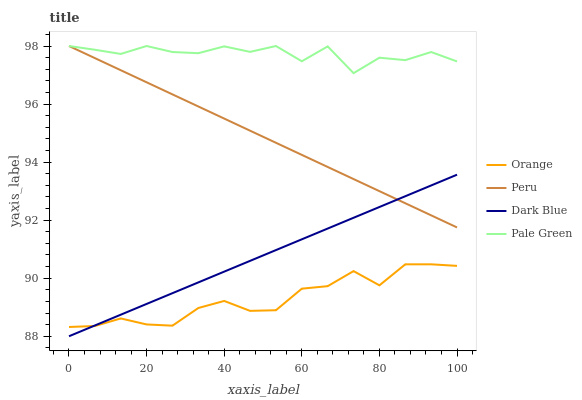Does Orange have the minimum area under the curve?
Answer yes or no. Yes. Does Pale Green have the maximum area under the curve?
Answer yes or no. Yes. Does Dark Blue have the minimum area under the curve?
Answer yes or no. No. Does Dark Blue have the maximum area under the curve?
Answer yes or no. No. Is Peru the smoothest?
Answer yes or no. Yes. Is Pale Green the roughest?
Answer yes or no. Yes. Is Dark Blue the smoothest?
Answer yes or no. No. Is Dark Blue the roughest?
Answer yes or no. No. Does Dark Blue have the lowest value?
Answer yes or no. Yes. Does Pale Green have the lowest value?
Answer yes or no. No. Does Peru have the highest value?
Answer yes or no. Yes. Does Dark Blue have the highest value?
Answer yes or no. No. Is Orange less than Pale Green?
Answer yes or no. Yes. Is Pale Green greater than Orange?
Answer yes or no. Yes. Does Dark Blue intersect Peru?
Answer yes or no. Yes. Is Dark Blue less than Peru?
Answer yes or no. No. Is Dark Blue greater than Peru?
Answer yes or no. No. Does Orange intersect Pale Green?
Answer yes or no. No. 